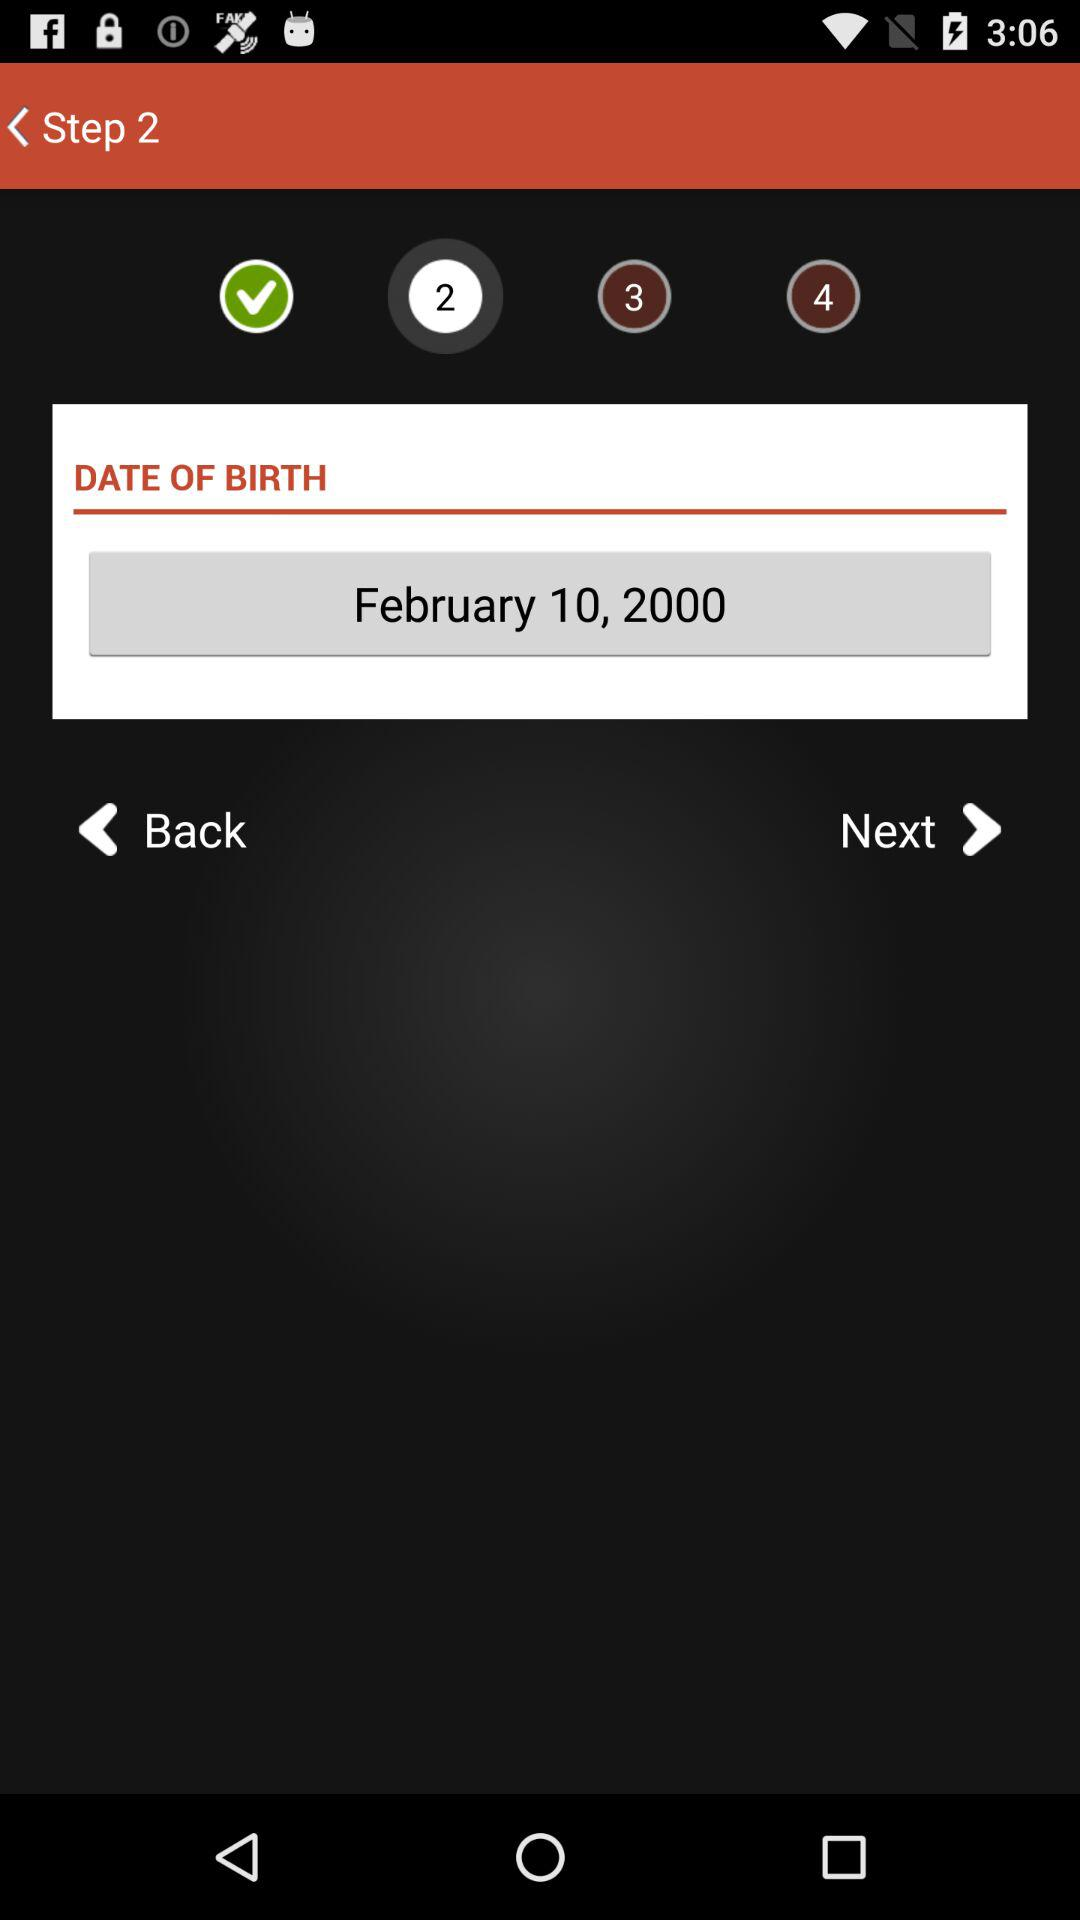What is the date of birth? The date of birth is 10th February, 2000. 